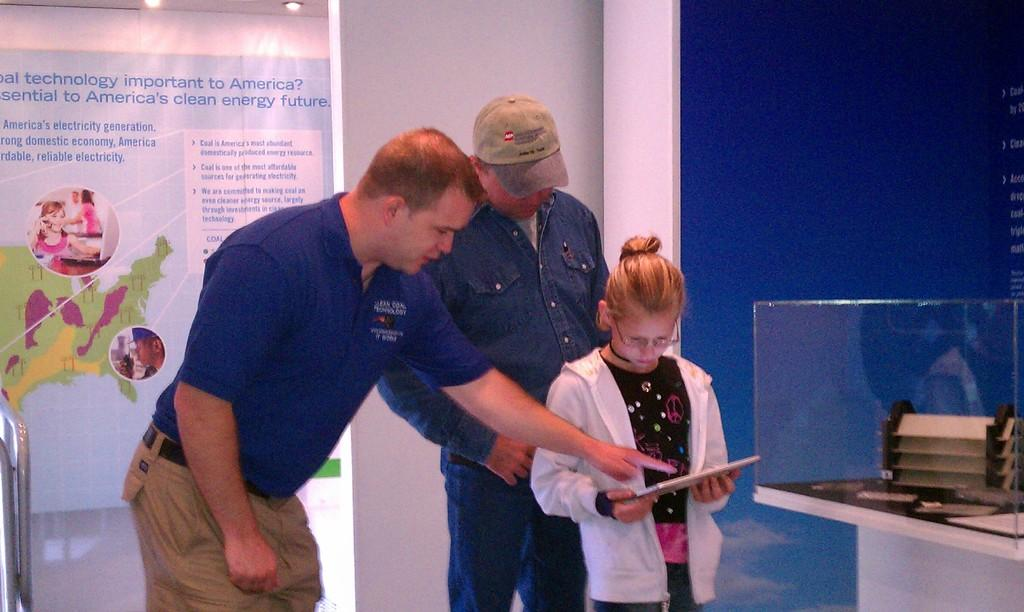<image>
Share a concise interpretation of the image provided. Two adults and a child look at something that has to do with clean energy. 